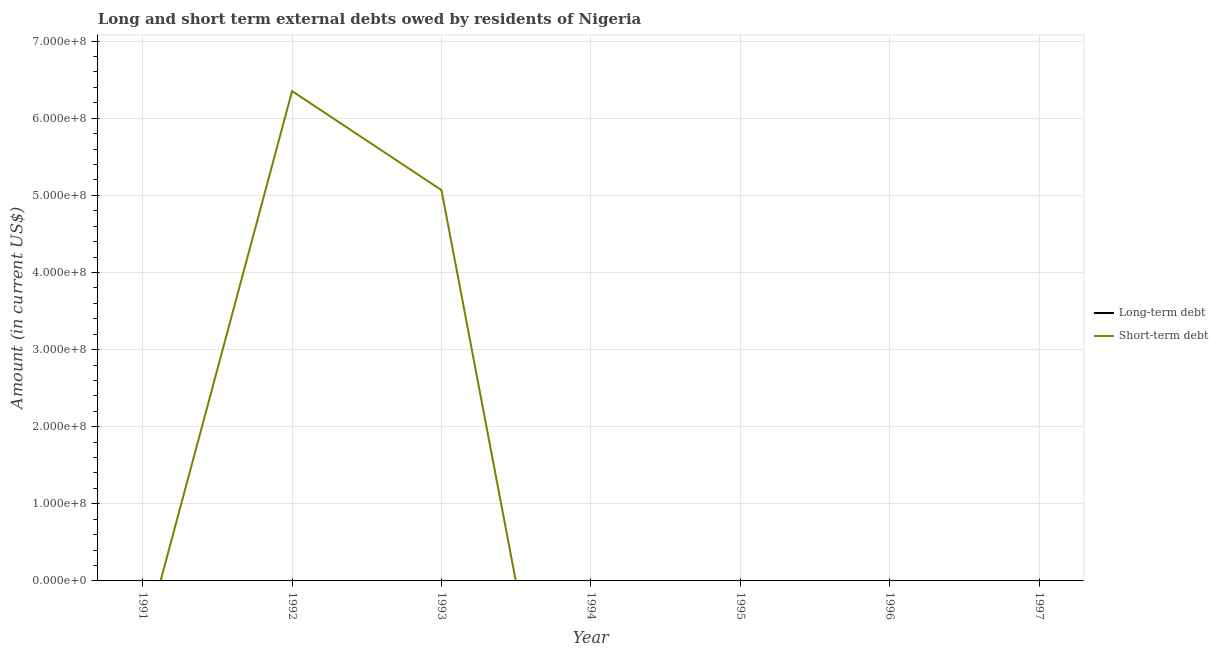Does the line corresponding to short-term debts owed by residents intersect with the line corresponding to long-term debts owed by residents?
Your answer should be compact. Yes. Is the number of lines equal to the number of legend labels?
Your response must be concise. No. What is the long-term debts owed by residents in 1995?
Offer a terse response. 0. Across all years, what is the maximum short-term debts owed by residents?
Your response must be concise. 6.35e+08. Across all years, what is the minimum short-term debts owed by residents?
Ensure brevity in your answer.  0. In which year was the short-term debts owed by residents maximum?
Give a very brief answer. 1992. What is the difference between the long-term debts owed by residents in 1991 and the short-term debts owed by residents in 1996?
Your response must be concise. 0. What is the average short-term debts owed by residents per year?
Keep it short and to the point. 1.63e+08. What is the difference between the highest and the lowest short-term debts owed by residents?
Offer a very short reply. 6.35e+08. In how many years, is the short-term debts owed by residents greater than the average short-term debts owed by residents taken over all years?
Offer a terse response. 2. How many years are there in the graph?
Make the answer very short. 7. Are the values on the major ticks of Y-axis written in scientific E-notation?
Your response must be concise. Yes. Does the graph contain grids?
Provide a short and direct response. Yes. How many legend labels are there?
Your answer should be very brief. 2. What is the title of the graph?
Provide a succinct answer. Long and short term external debts owed by residents of Nigeria. What is the Amount (in current US$) in Long-term debt in 1992?
Your answer should be compact. 0. What is the Amount (in current US$) of Short-term debt in 1992?
Your answer should be compact. 6.35e+08. What is the Amount (in current US$) in Short-term debt in 1993?
Make the answer very short. 5.07e+08. What is the Amount (in current US$) in Long-term debt in 1994?
Provide a short and direct response. 0. What is the Amount (in current US$) in Short-term debt in 1995?
Provide a succinct answer. 0. What is the Amount (in current US$) in Long-term debt in 1996?
Ensure brevity in your answer.  0. What is the Amount (in current US$) of Short-term debt in 1996?
Your response must be concise. 0. What is the Amount (in current US$) in Short-term debt in 1997?
Offer a very short reply. 0. Across all years, what is the maximum Amount (in current US$) in Short-term debt?
Keep it short and to the point. 6.35e+08. Across all years, what is the minimum Amount (in current US$) in Short-term debt?
Your answer should be very brief. 0. What is the total Amount (in current US$) of Short-term debt in the graph?
Give a very brief answer. 1.14e+09. What is the difference between the Amount (in current US$) of Short-term debt in 1992 and that in 1993?
Provide a succinct answer. 1.28e+08. What is the average Amount (in current US$) in Short-term debt per year?
Offer a very short reply. 1.63e+08. What is the ratio of the Amount (in current US$) of Short-term debt in 1992 to that in 1993?
Offer a very short reply. 1.25. What is the difference between the highest and the lowest Amount (in current US$) in Short-term debt?
Ensure brevity in your answer.  6.35e+08. 